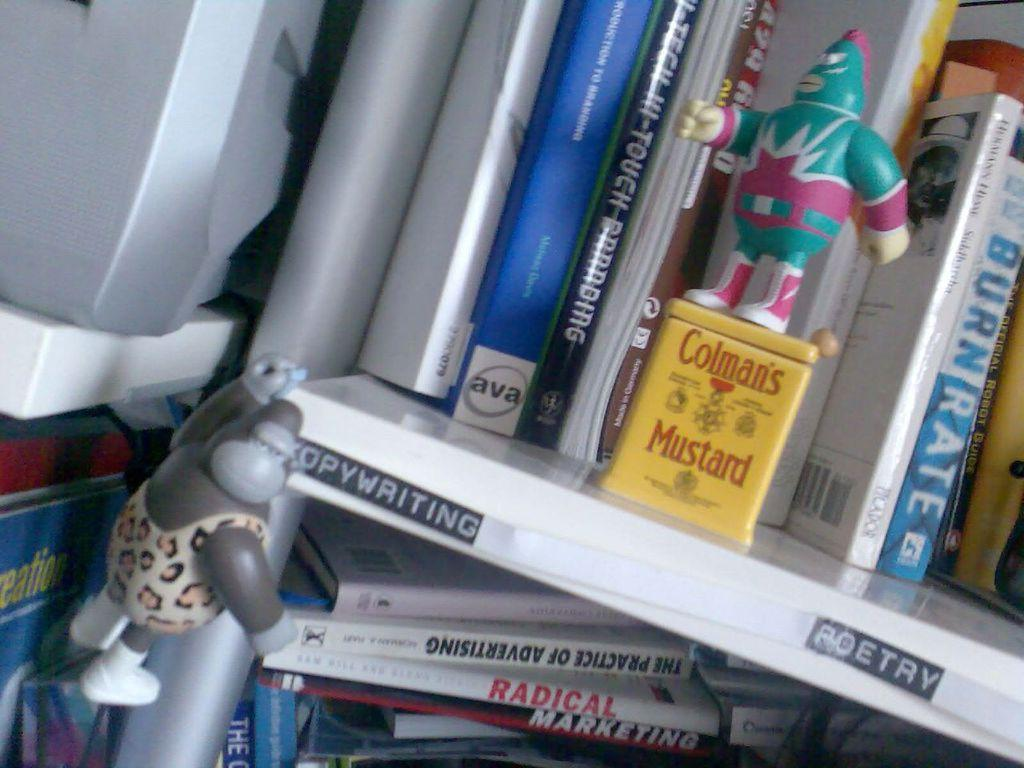<image>
Provide a brief description of the given image. A couple of shelves of books are labeled poetry and copywriting. 